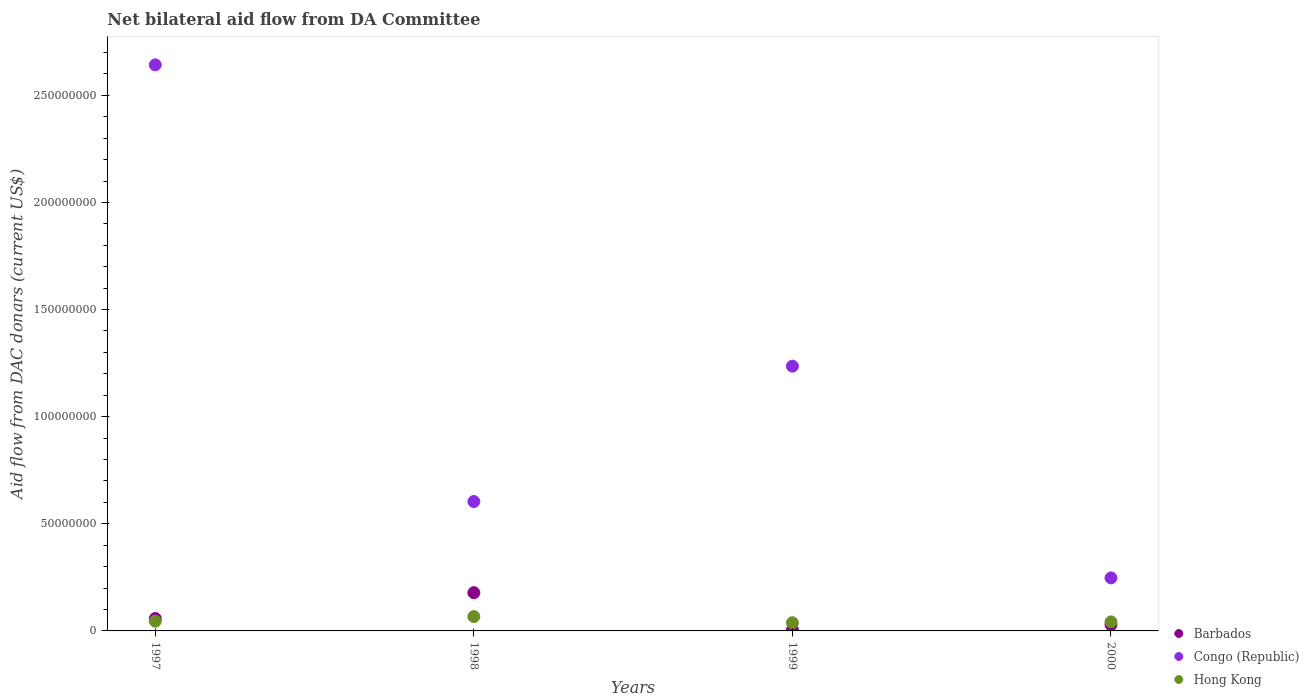How many different coloured dotlines are there?
Keep it short and to the point. 3. What is the aid flow in in Congo (Republic) in 1997?
Your response must be concise. 2.64e+08. Across all years, what is the maximum aid flow in in Barbados?
Give a very brief answer. 1.78e+07. Across all years, what is the minimum aid flow in in Congo (Republic)?
Offer a terse response. 2.48e+07. In which year was the aid flow in in Hong Kong minimum?
Ensure brevity in your answer.  1999. What is the total aid flow in in Barbados in the graph?
Your answer should be compact. 2.70e+07. What is the difference between the aid flow in in Barbados in 1997 and that in 1998?
Your response must be concise. -1.21e+07. What is the difference between the aid flow in in Hong Kong in 1998 and the aid flow in in Barbados in 1999?
Provide a short and direct response. 6.24e+06. What is the average aid flow in in Barbados per year?
Give a very brief answer. 6.74e+06. In the year 2000, what is the difference between the aid flow in in Hong Kong and aid flow in in Barbados?
Your answer should be very brief. 1.33e+06. In how many years, is the aid flow in in Barbados greater than 150000000 US$?
Your answer should be compact. 0. What is the ratio of the aid flow in in Barbados in 1998 to that in 1999?
Your answer should be very brief. 38.8. Is the aid flow in in Hong Kong in 1997 less than that in 1998?
Provide a succinct answer. Yes. Is the difference between the aid flow in in Hong Kong in 1998 and 1999 greater than the difference between the aid flow in in Barbados in 1998 and 1999?
Provide a short and direct response. No. What is the difference between the highest and the second highest aid flow in in Barbados?
Make the answer very short. 1.21e+07. What is the difference between the highest and the lowest aid flow in in Congo (Republic)?
Offer a very short reply. 2.39e+08. Is the sum of the aid flow in in Hong Kong in 1997 and 2000 greater than the maximum aid flow in in Congo (Republic) across all years?
Offer a very short reply. No. Does the aid flow in in Hong Kong monotonically increase over the years?
Your answer should be compact. No. Is the aid flow in in Barbados strictly greater than the aid flow in in Hong Kong over the years?
Offer a very short reply. No. How many years are there in the graph?
Keep it short and to the point. 4. Does the graph contain any zero values?
Offer a terse response. No. Does the graph contain grids?
Your response must be concise. No. Where does the legend appear in the graph?
Provide a short and direct response. Bottom right. What is the title of the graph?
Make the answer very short. Net bilateral aid flow from DA Committee. Does "Latvia" appear as one of the legend labels in the graph?
Keep it short and to the point. No. What is the label or title of the Y-axis?
Ensure brevity in your answer.  Aid flow from DAC donars (current US$). What is the Aid flow from DAC donars (current US$) of Barbados in 1997?
Provide a short and direct response. 5.78e+06. What is the Aid flow from DAC donars (current US$) in Congo (Republic) in 1997?
Keep it short and to the point. 2.64e+08. What is the Aid flow from DAC donars (current US$) of Hong Kong in 1997?
Provide a short and direct response. 4.55e+06. What is the Aid flow from DAC donars (current US$) of Barbados in 1998?
Offer a very short reply. 1.78e+07. What is the Aid flow from DAC donars (current US$) of Congo (Republic) in 1998?
Ensure brevity in your answer.  6.04e+07. What is the Aid flow from DAC donars (current US$) of Hong Kong in 1998?
Make the answer very short. 6.70e+06. What is the Aid flow from DAC donars (current US$) in Congo (Republic) in 1999?
Your response must be concise. 1.24e+08. What is the Aid flow from DAC donars (current US$) of Hong Kong in 1999?
Your answer should be compact. 3.82e+06. What is the Aid flow from DAC donars (current US$) of Barbados in 2000?
Give a very brief answer. 2.89e+06. What is the Aid flow from DAC donars (current US$) of Congo (Republic) in 2000?
Your response must be concise. 2.48e+07. What is the Aid flow from DAC donars (current US$) of Hong Kong in 2000?
Give a very brief answer. 4.22e+06. Across all years, what is the maximum Aid flow from DAC donars (current US$) of Barbados?
Provide a succinct answer. 1.78e+07. Across all years, what is the maximum Aid flow from DAC donars (current US$) in Congo (Republic)?
Offer a terse response. 2.64e+08. Across all years, what is the maximum Aid flow from DAC donars (current US$) of Hong Kong?
Provide a succinct answer. 6.70e+06. Across all years, what is the minimum Aid flow from DAC donars (current US$) of Barbados?
Make the answer very short. 4.60e+05. Across all years, what is the minimum Aid flow from DAC donars (current US$) in Congo (Republic)?
Your response must be concise. 2.48e+07. Across all years, what is the minimum Aid flow from DAC donars (current US$) of Hong Kong?
Your response must be concise. 3.82e+06. What is the total Aid flow from DAC donars (current US$) in Barbados in the graph?
Provide a short and direct response. 2.70e+07. What is the total Aid flow from DAC donars (current US$) of Congo (Republic) in the graph?
Your answer should be compact. 4.73e+08. What is the total Aid flow from DAC donars (current US$) in Hong Kong in the graph?
Make the answer very short. 1.93e+07. What is the difference between the Aid flow from DAC donars (current US$) of Barbados in 1997 and that in 1998?
Offer a very short reply. -1.21e+07. What is the difference between the Aid flow from DAC donars (current US$) in Congo (Republic) in 1997 and that in 1998?
Give a very brief answer. 2.04e+08. What is the difference between the Aid flow from DAC donars (current US$) of Hong Kong in 1997 and that in 1998?
Your response must be concise. -2.15e+06. What is the difference between the Aid flow from DAC donars (current US$) in Barbados in 1997 and that in 1999?
Provide a short and direct response. 5.32e+06. What is the difference between the Aid flow from DAC donars (current US$) in Congo (Republic) in 1997 and that in 1999?
Make the answer very short. 1.41e+08. What is the difference between the Aid flow from DAC donars (current US$) of Hong Kong in 1997 and that in 1999?
Your response must be concise. 7.30e+05. What is the difference between the Aid flow from DAC donars (current US$) of Barbados in 1997 and that in 2000?
Provide a short and direct response. 2.89e+06. What is the difference between the Aid flow from DAC donars (current US$) in Congo (Republic) in 1997 and that in 2000?
Provide a succinct answer. 2.39e+08. What is the difference between the Aid flow from DAC donars (current US$) of Barbados in 1998 and that in 1999?
Provide a succinct answer. 1.74e+07. What is the difference between the Aid flow from DAC donars (current US$) in Congo (Republic) in 1998 and that in 1999?
Offer a terse response. -6.32e+07. What is the difference between the Aid flow from DAC donars (current US$) of Hong Kong in 1998 and that in 1999?
Your response must be concise. 2.88e+06. What is the difference between the Aid flow from DAC donars (current US$) of Barbados in 1998 and that in 2000?
Give a very brief answer. 1.50e+07. What is the difference between the Aid flow from DAC donars (current US$) of Congo (Republic) in 1998 and that in 2000?
Provide a succinct answer. 3.56e+07. What is the difference between the Aid flow from DAC donars (current US$) of Hong Kong in 1998 and that in 2000?
Keep it short and to the point. 2.48e+06. What is the difference between the Aid flow from DAC donars (current US$) in Barbados in 1999 and that in 2000?
Keep it short and to the point. -2.43e+06. What is the difference between the Aid flow from DAC donars (current US$) in Congo (Republic) in 1999 and that in 2000?
Make the answer very short. 9.88e+07. What is the difference between the Aid flow from DAC donars (current US$) in Hong Kong in 1999 and that in 2000?
Ensure brevity in your answer.  -4.00e+05. What is the difference between the Aid flow from DAC donars (current US$) in Barbados in 1997 and the Aid flow from DAC donars (current US$) in Congo (Republic) in 1998?
Provide a succinct answer. -5.46e+07. What is the difference between the Aid flow from DAC donars (current US$) of Barbados in 1997 and the Aid flow from DAC donars (current US$) of Hong Kong in 1998?
Provide a short and direct response. -9.20e+05. What is the difference between the Aid flow from DAC donars (current US$) of Congo (Republic) in 1997 and the Aid flow from DAC donars (current US$) of Hong Kong in 1998?
Your answer should be very brief. 2.58e+08. What is the difference between the Aid flow from DAC donars (current US$) in Barbados in 1997 and the Aid flow from DAC donars (current US$) in Congo (Republic) in 1999?
Provide a succinct answer. -1.18e+08. What is the difference between the Aid flow from DAC donars (current US$) in Barbados in 1997 and the Aid flow from DAC donars (current US$) in Hong Kong in 1999?
Offer a very short reply. 1.96e+06. What is the difference between the Aid flow from DAC donars (current US$) in Congo (Republic) in 1997 and the Aid flow from DAC donars (current US$) in Hong Kong in 1999?
Offer a terse response. 2.60e+08. What is the difference between the Aid flow from DAC donars (current US$) in Barbados in 1997 and the Aid flow from DAC donars (current US$) in Congo (Republic) in 2000?
Your response must be concise. -1.90e+07. What is the difference between the Aid flow from DAC donars (current US$) in Barbados in 1997 and the Aid flow from DAC donars (current US$) in Hong Kong in 2000?
Make the answer very short. 1.56e+06. What is the difference between the Aid flow from DAC donars (current US$) of Congo (Republic) in 1997 and the Aid flow from DAC donars (current US$) of Hong Kong in 2000?
Offer a very short reply. 2.60e+08. What is the difference between the Aid flow from DAC donars (current US$) in Barbados in 1998 and the Aid flow from DAC donars (current US$) in Congo (Republic) in 1999?
Your response must be concise. -1.06e+08. What is the difference between the Aid flow from DAC donars (current US$) in Barbados in 1998 and the Aid flow from DAC donars (current US$) in Hong Kong in 1999?
Give a very brief answer. 1.40e+07. What is the difference between the Aid flow from DAC donars (current US$) of Congo (Republic) in 1998 and the Aid flow from DAC donars (current US$) of Hong Kong in 1999?
Provide a short and direct response. 5.66e+07. What is the difference between the Aid flow from DAC donars (current US$) of Barbados in 1998 and the Aid flow from DAC donars (current US$) of Congo (Republic) in 2000?
Your answer should be very brief. -6.91e+06. What is the difference between the Aid flow from DAC donars (current US$) in Barbados in 1998 and the Aid flow from DAC donars (current US$) in Hong Kong in 2000?
Your answer should be very brief. 1.36e+07. What is the difference between the Aid flow from DAC donars (current US$) of Congo (Republic) in 1998 and the Aid flow from DAC donars (current US$) of Hong Kong in 2000?
Offer a very short reply. 5.62e+07. What is the difference between the Aid flow from DAC donars (current US$) in Barbados in 1999 and the Aid flow from DAC donars (current US$) in Congo (Republic) in 2000?
Give a very brief answer. -2.43e+07. What is the difference between the Aid flow from DAC donars (current US$) in Barbados in 1999 and the Aid flow from DAC donars (current US$) in Hong Kong in 2000?
Provide a short and direct response. -3.76e+06. What is the difference between the Aid flow from DAC donars (current US$) of Congo (Republic) in 1999 and the Aid flow from DAC donars (current US$) of Hong Kong in 2000?
Your answer should be compact. 1.19e+08. What is the average Aid flow from DAC donars (current US$) in Barbados per year?
Offer a terse response. 6.74e+06. What is the average Aid flow from DAC donars (current US$) in Congo (Republic) per year?
Provide a short and direct response. 1.18e+08. What is the average Aid flow from DAC donars (current US$) in Hong Kong per year?
Provide a short and direct response. 4.82e+06. In the year 1997, what is the difference between the Aid flow from DAC donars (current US$) of Barbados and Aid flow from DAC donars (current US$) of Congo (Republic)?
Give a very brief answer. -2.58e+08. In the year 1997, what is the difference between the Aid flow from DAC donars (current US$) in Barbados and Aid flow from DAC donars (current US$) in Hong Kong?
Provide a short and direct response. 1.23e+06. In the year 1997, what is the difference between the Aid flow from DAC donars (current US$) in Congo (Republic) and Aid flow from DAC donars (current US$) in Hong Kong?
Give a very brief answer. 2.60e+08. In the year 1998, what is the difference between the Aid flow from DAC donars (current US$) of Barbados and Aid flow from DAC donars (current US$) of Congo (Republic)?
Your answer should be very brief. -4.26e+07. In the year 1998, what is the difference between the Aid flow from DAC donars (current US$) of Barbados and Aid flow from DAC donars (current US$) of Hong Kong?
Keep it short and to the point. 1.12e+07. In the year 1998, what is the difference between the Aid flow from DAC donars (current US$) in Congo (Republic) and Aid flow from DAC donars (current US$) in Hong Kong?
Make the answer very short. 5.37e+07. In the year 1999, what is the difference between the Aid flow from DAC donars (current US$) of Barbados and Aid flow from DAC donars (current US$) of Congo (Republic)?
Your response must be concise. -1.23e+08. In the year 1999, what is the difference between the Aid flow from DAC donars (current US$) in Barbados and Aid flow from DAC donars (current US$) in Hong Kong?
Your answer should be very brief. -3.36e+06. In the year 1999, what is the difference between the Aid flow from DAC donars (current US$) of Congo (Republic) and Aid flow from DAC donars (current US$) of Hong Kong?
Give a very brief answer. 1.20e+08. In the year 2000, what is the difference between the Aid flow from DAC donars (current US$) of Barbados and Aid flow from DAC donars (current US$) of Congo (Republic)?
Offer a terse response. -2.19e+07. In the year 2000, what is the difference between the Aid flow from DAC donars (current US$) of Barbados and Aid flow from DAC donars (current US$) of Hong Kong?
Ensure brevity in your answer.  -1.33e+06. In the year 2000, what is the difference between the Aid flow from DAC donars (current US$) of Congo (Republic) and Aid flow from DAC donars (current US$) of Hong Kong?
Provide a succinct answer. 2.05e+07. What is the ratio of the Aid flow from DAC donars (current US$) in Barbados in 1997 to that in 1998?
Offer a terse response. 0.32. What is the ratio of the Aid flow from DAC donars (current US$) in Congo (Republic) in 1997 to that in 1998?
Make the answer very short. 4.37. What is the ratio of the Aid flow from DAC donars (current US$) in Hong Kong in 1997 to that in 1998?
Keep it short and to the point. 0.68. What is the ratio of the Aid flow from DAC donars (current US$) in Barbados in 1997 to that in 1999?
Your response must be concise. 12.57. What is the ratio of the Aid flow from DAC donars (current US$) of Congo (Republic) in 1997 to that in 1999?
Provide a succinct answer. 2.14. What is the ratio of the Aid flow from DAC donars (current US$) in Hong Kong in 1997 to that in 1999?
Offer a very short reply. 1.19. What is the ratio of the Aid flow from DAC donars (current US$) in Barbados in 1997 to that in 2000?
Offer a very short reply. 2. What is the ratio of the Aid flow from DAC donars (current US$) in Congo (Republic) in 1997 to that in 2000?
Offer a terse response. 10.67. What is the ratio of the Aid flow from DAC donars (current US$) in Hong Kong in 1997 to that in 2000?
Ensure brevity in your answer.  1.08. What is the ratio of the Aid flow from DAC donars (current US$) of Barbados in 1998 to that in 1999?
Your answer should be compact. 38.8. What is the ratio of the Aid flow from DAC donars (current US$) in Congo (Republic) in 1998 to that in 1999?
Make the answer very short. 0.49. What is the ratio of the Aid flow from DAC donars (current US$) of Hong Kong in 1998 to that in 1999?
Offer a terse response. 1.75. What is the ratio of the Aid flow from DAC donars (current US$) of Barbados in 1998 to that in 2000?
Provide a short and direct response. 6.18. What is the ratio of the Aid flow from DAC donars (current US$) of Congo (Republic) in 1998 to that in 2000?
Your answer should be very brief. 2.44. What is the ratio of the Aid flow from DAC donars (current US$) of Hong Kong in 1998 to that in 2000?
Your answer should be very brief. 1.59. What is the ratio of the Aid flow from DAC donars (current US$) in Barbados in 1999 to that in 2000?
Make the answer very short. 0.16. What is the ratio of the Aid flow from DAC donars (current US$) in Congo (Republic) in 1999 to that in 2000?
Keep it short and to the point. 4.99. What is the ratio of the Aid flow from DAC donars (current US$) of Hong Kong in 1999 to that in 2000?
Keep it short and to the point. 0.91. What is the difference between the highest and the second highest Aid flow from DAC donars (current US$) of Barbados?
Provide a succinct answer. 1.21e+07. What is the difference between the highest and the second highest Aid flow from DAC donars (current US$) of Congo (Republic)?
Your answer should be very brief. 1.41e+08. What is the difference between the highest and the second highest Aid flow from DAC donars (current US$) of Hong Kong?
Offer a very short reply. 2.15e+06. What is the difference between the highest and the lowest Aid flow from DAC donars (current US$) of Barbados?
Keep it short and to the point. 1.74e+07. What is the difference between the highest and the lowest Aid flow from DAC donars (current US$) in Congo (Republic)?
Give a very brief answer. 2.39e+08. What is the difference between the highest and the lowest Aid flow from DAC donars (current US$) in Hong Kong?
Give a very brief answer. 2.88e+06. 